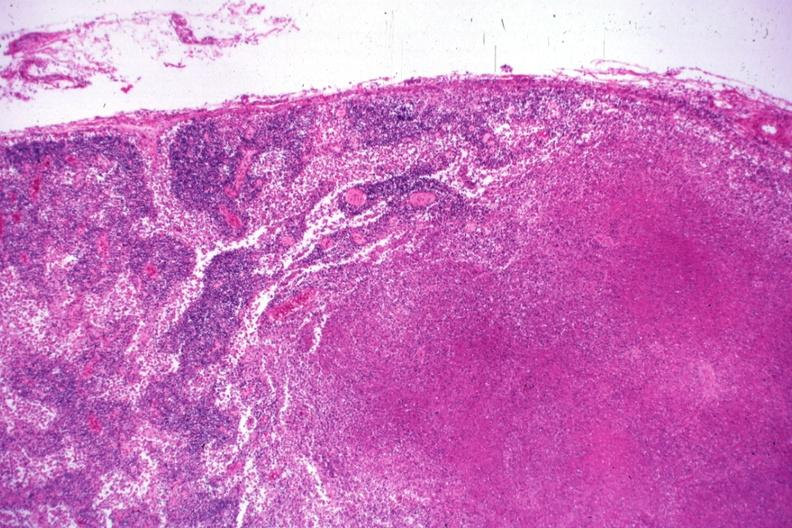does lymphoblastic lymphoma show low typical necrotizing lesion?
Answer the question using a single word or phrase. No 